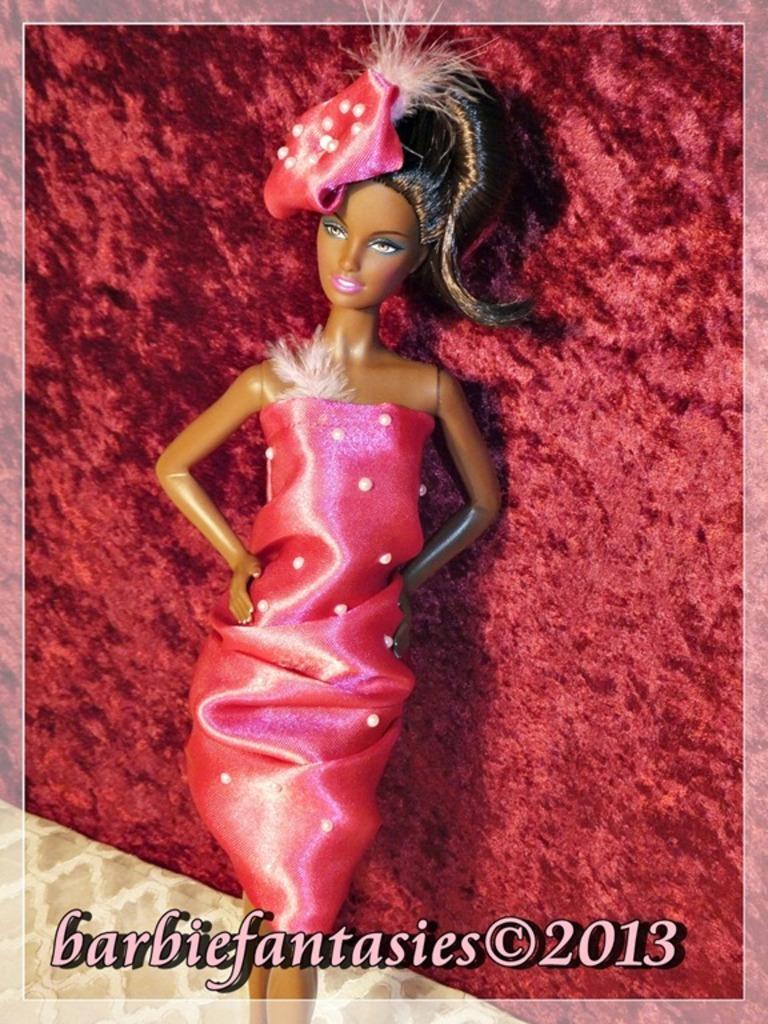Could you give a brief overview of what you see in this image? In this image I can see a barbie doll with a red background and at the bottom of the image I can see some text. 